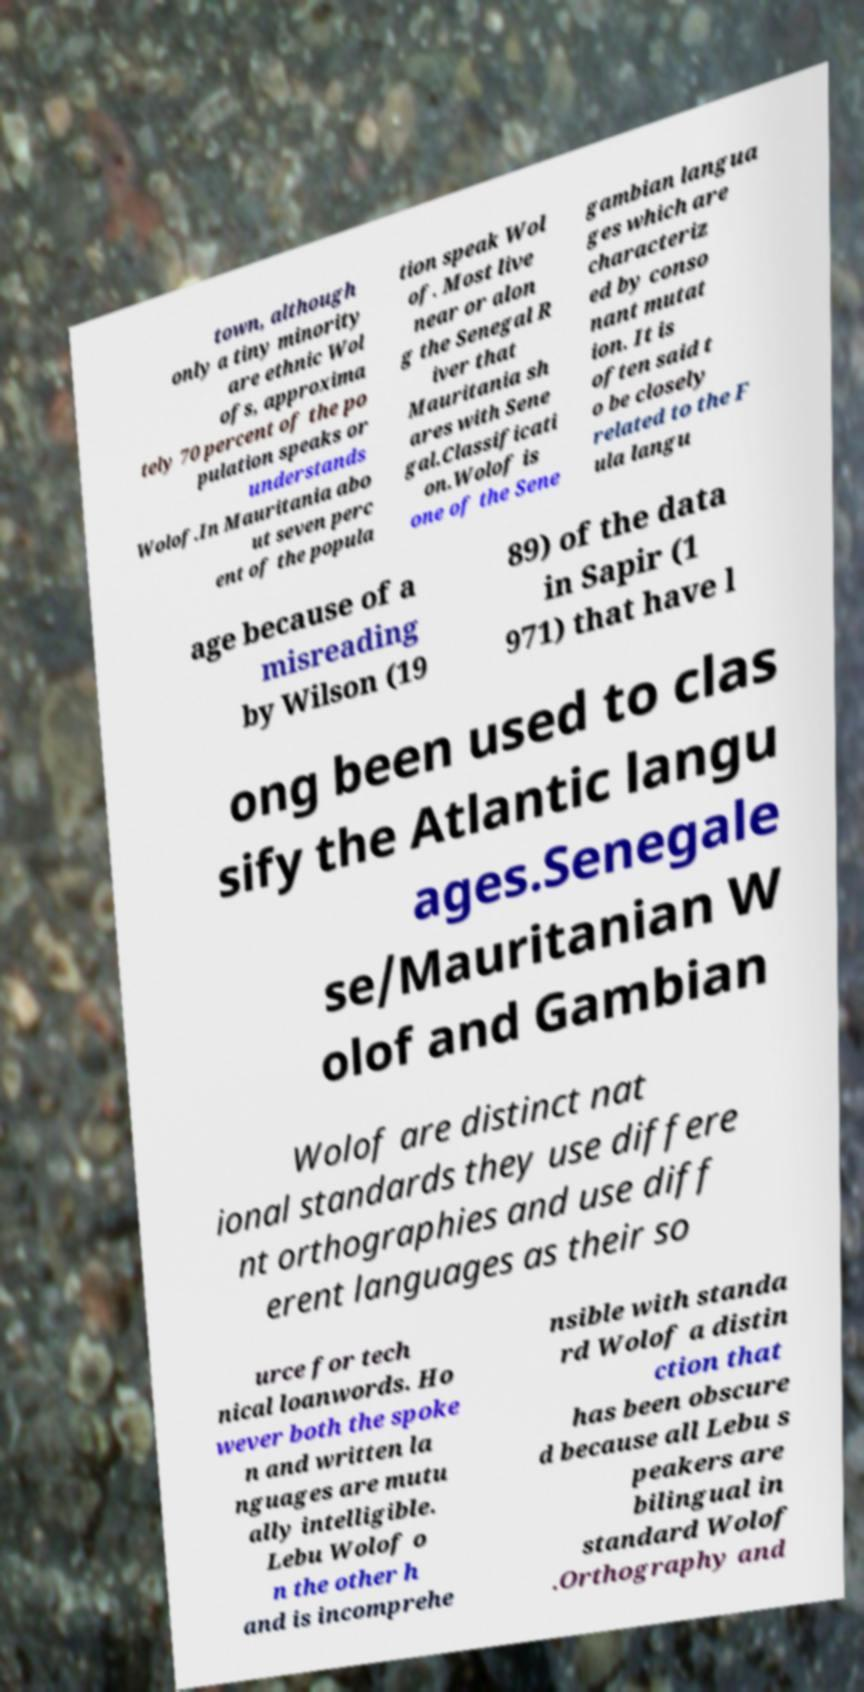There's text embedded in this image that I need extracted. Can you transcribe it verbatim? town, although only a tiny minority are ethnic Wol ofs, approxima tely 70 percent of the po pulation speaks or understands Wolof.In Mauritania abo ut seven perc ent of the popula tion speak Wol of. Most live near or alon g the Senegal R iver that Mauritania sh ares with Sene gal.Classificati on.Wolof is one of the Sene gambian langua ges which are characteriz ed by conso nant mutat ion. It is often said t o be closely related to the F ula langu age because of a misreading by Wilson (19 89) of the data in Sapir (1 971) that have l ong been used to clas sify the Atlantic langu ages.Senegale se/Mauritanian W olof and Gambian Wolof are distinct nat ional standards they use differe nt orthographies and use diff erent languages as their so urce for tech nical loanwords. Ho wever both the spoke n and written la nguages are mutu ally intelligible. Lebu Wolof o n the other h and is incomprehe nsible with standa rd Wolof a distin ction that has been obscure d because all Lebu s peakers are bilingual in standard Wolof .Orthography and 